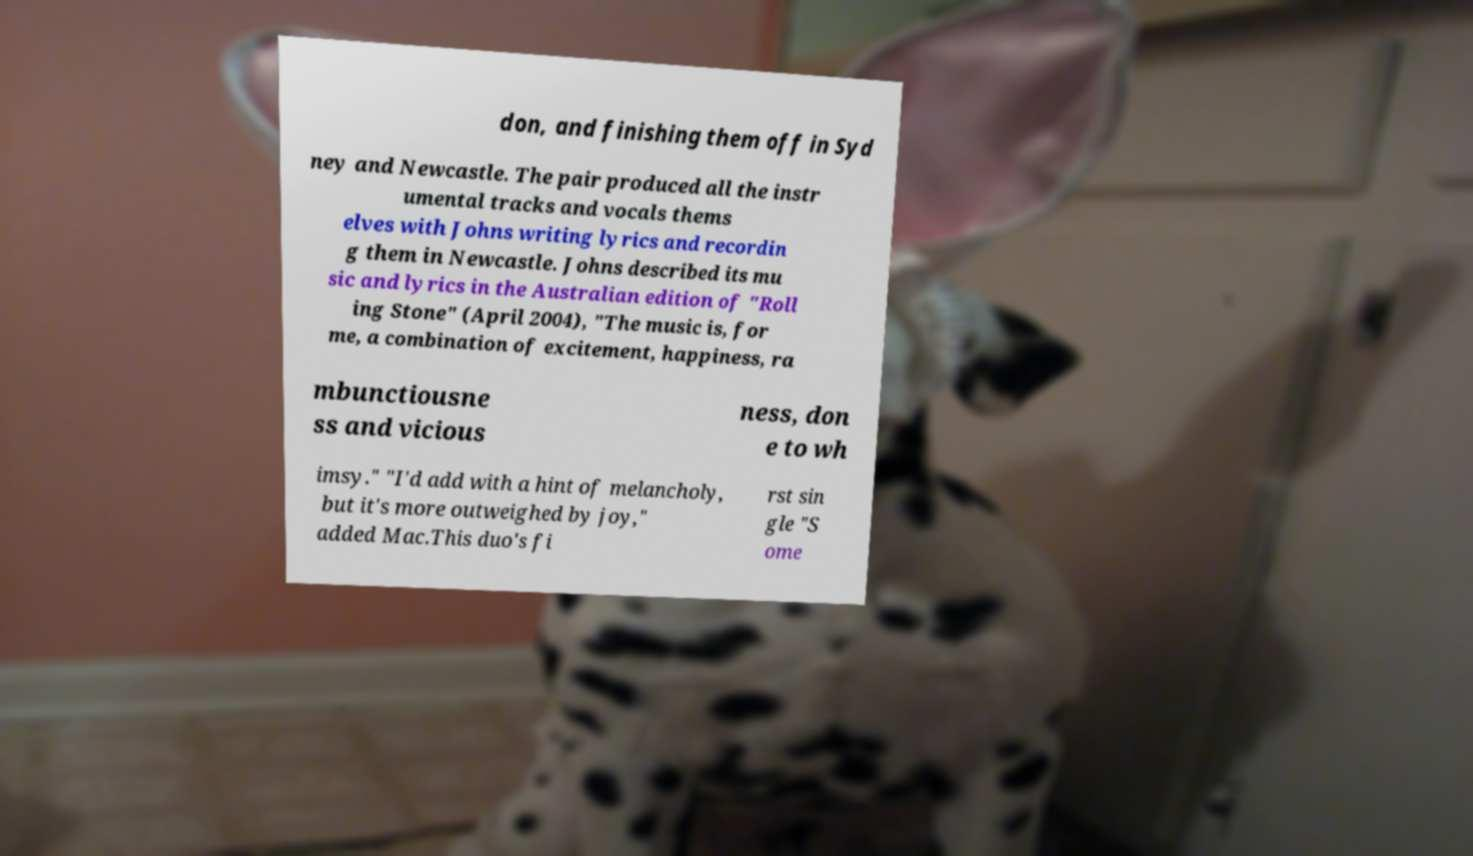For documentation purposes, I need the text within this image transcribed. Could you provide that? don, and finishing them off in Syd ney and Newcastle. The pair produced all the instr umental tracks and vocals thems elves with Johns writing lyrics and recordin g them in Newcastle. Johns described its mu sic and lyrics in the Australian edition of "Roll ing Stone" (April 2004), "The music is, for me, a combination of excitement, happiness, ra mbunctiousne ss and vicious ness, don e to wh imsy." "I'd add with a hint of melancholy, but it's more outweighed by joy," added Mac.This duo's fi rst sin gle "S ome 